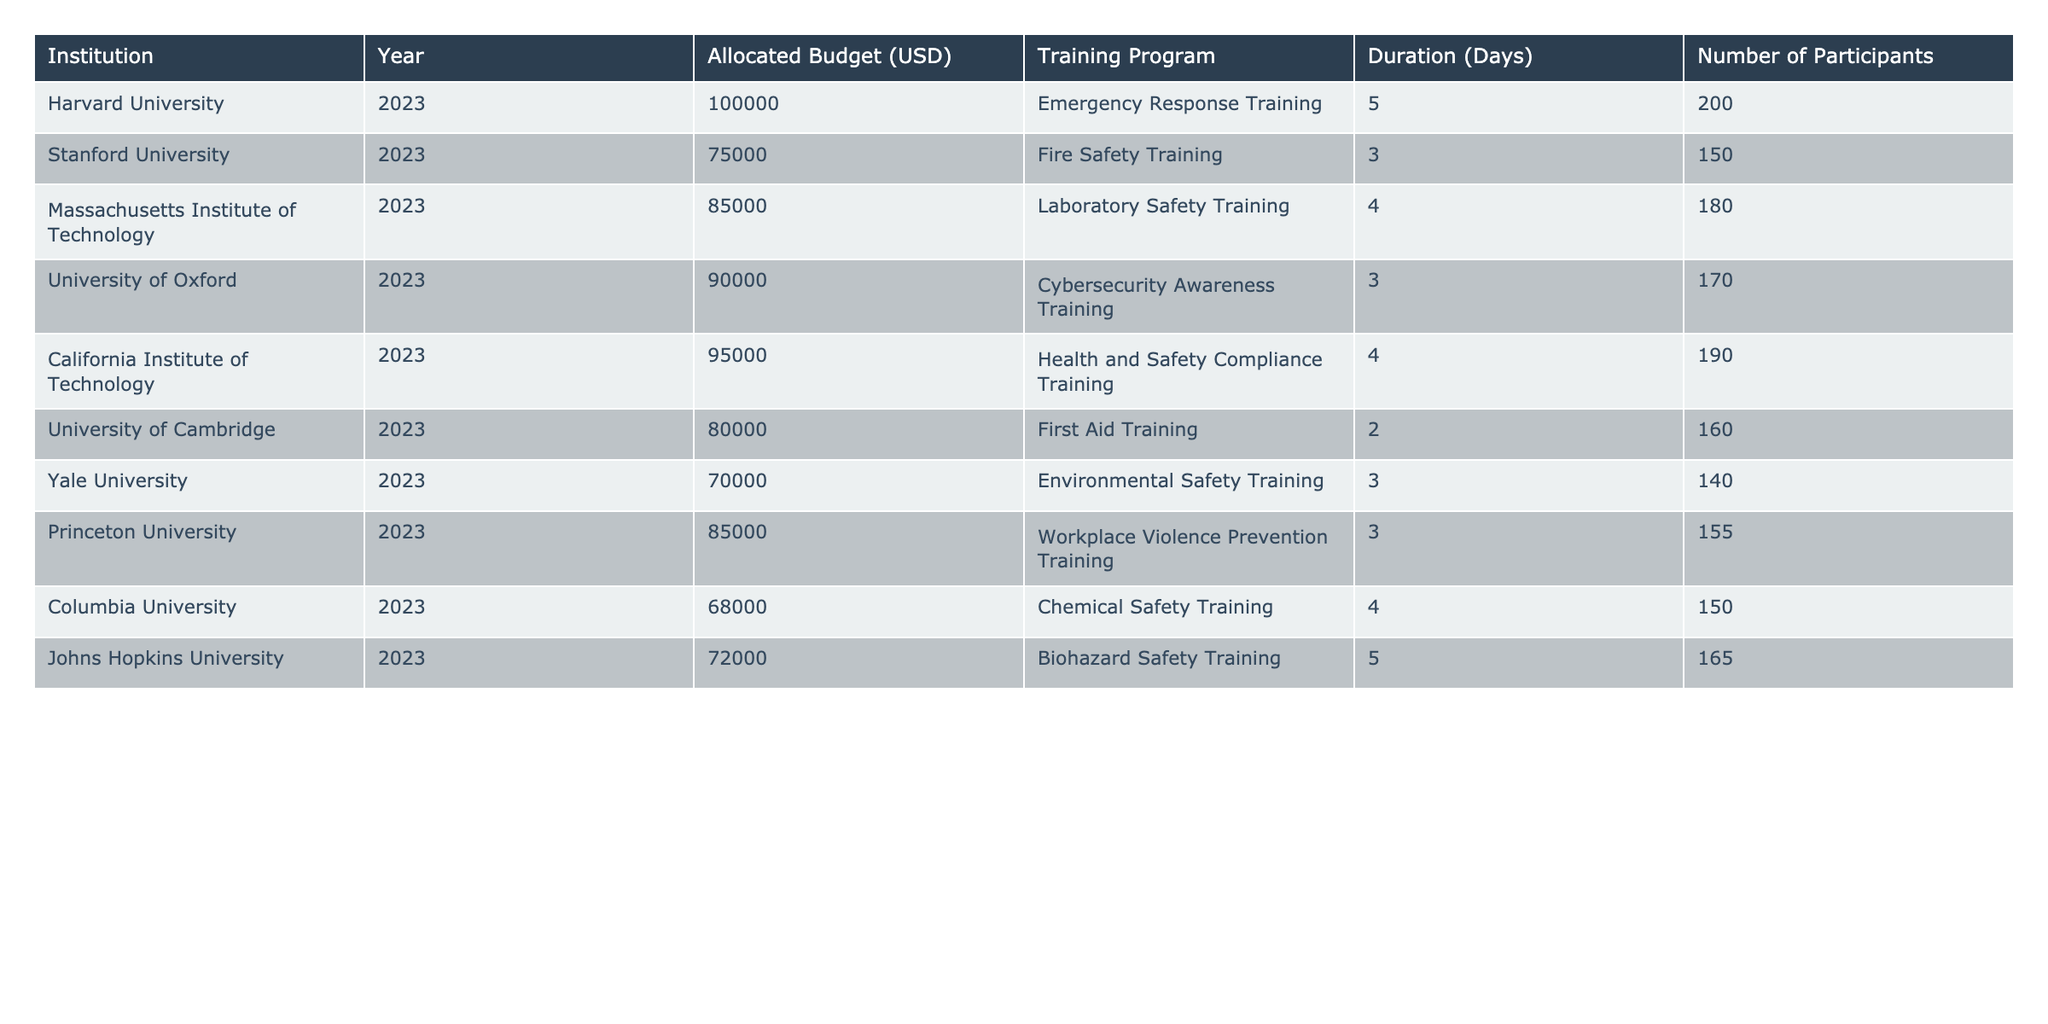What is the allocated budget for Stanford University? The table shows that the allocated budget for Stanford University in 2023 is 75,000 USD.
Answer: 75,000 USD Which training program had the highest budget allocation? By reviewing the budget allocations for all the institutions, Harvard University has the highest budget allocation of 100,000 USD for Emergency Response Training.
Answer: 100,000 USD What is the total number of participants across all institutions? To find the total number of participants, we add the number of participants for each institution: 200 + 150 + 180 + 170 + 190 + 160 + 140 + 155 + 150 + 165 = 1,660.
Answer: 1,660 Does Yale University have the lowest allocated budget? Comparing all allocated budgets in the table, Yale University's budget of 70,000 USD is indeed the lowest among all the listed institutions.
Answer: Yes What is the average duration of the training programs listed in the table? The average duration is calculated by summing the duration of all training programs and dividing by the number of programs: (5 + 3 + 4 + 3 + 4 + 2 + 3 + 3 + 4 + 5) = 38 days total for 10 programs, so the average duration is 38 / 10 = 3.8 days.
Answer: 3.8 days What percentage of the total allocated budget does the California Institute of Technology represent? First, we need to find the total allocated budget, which is 100,000 + 75,000 + 85,000 + 90,000 + 95,000 + 80,000 + 70,000 + 85,000 + 68,000 + 72,000 = 1,030,000 USD. Next, we find the percentage: (95,000 / 1,030,000) * 100 = approximately 9.22%.
Answer: 9.22% Which institution has a longer training program duration, Harvard University or Johns Hopkins University? Harvard University offers a training program with a duration of 5 days, while Johns Hopkins University has a 5-day duration as well. Since both durations are equal, neither is longer.
Answer: Neither is longer What is the budget difference between Massachusetts Institute of Technology and Princeton University? To find the budget difference, subtract Princeton University's budget (85,000 USD) from Massachusetts Institute of Technology's budget (85,000 USD): 85,000 - 85,000 = 0, meaning there is no difference.
Answer: 0 USD 